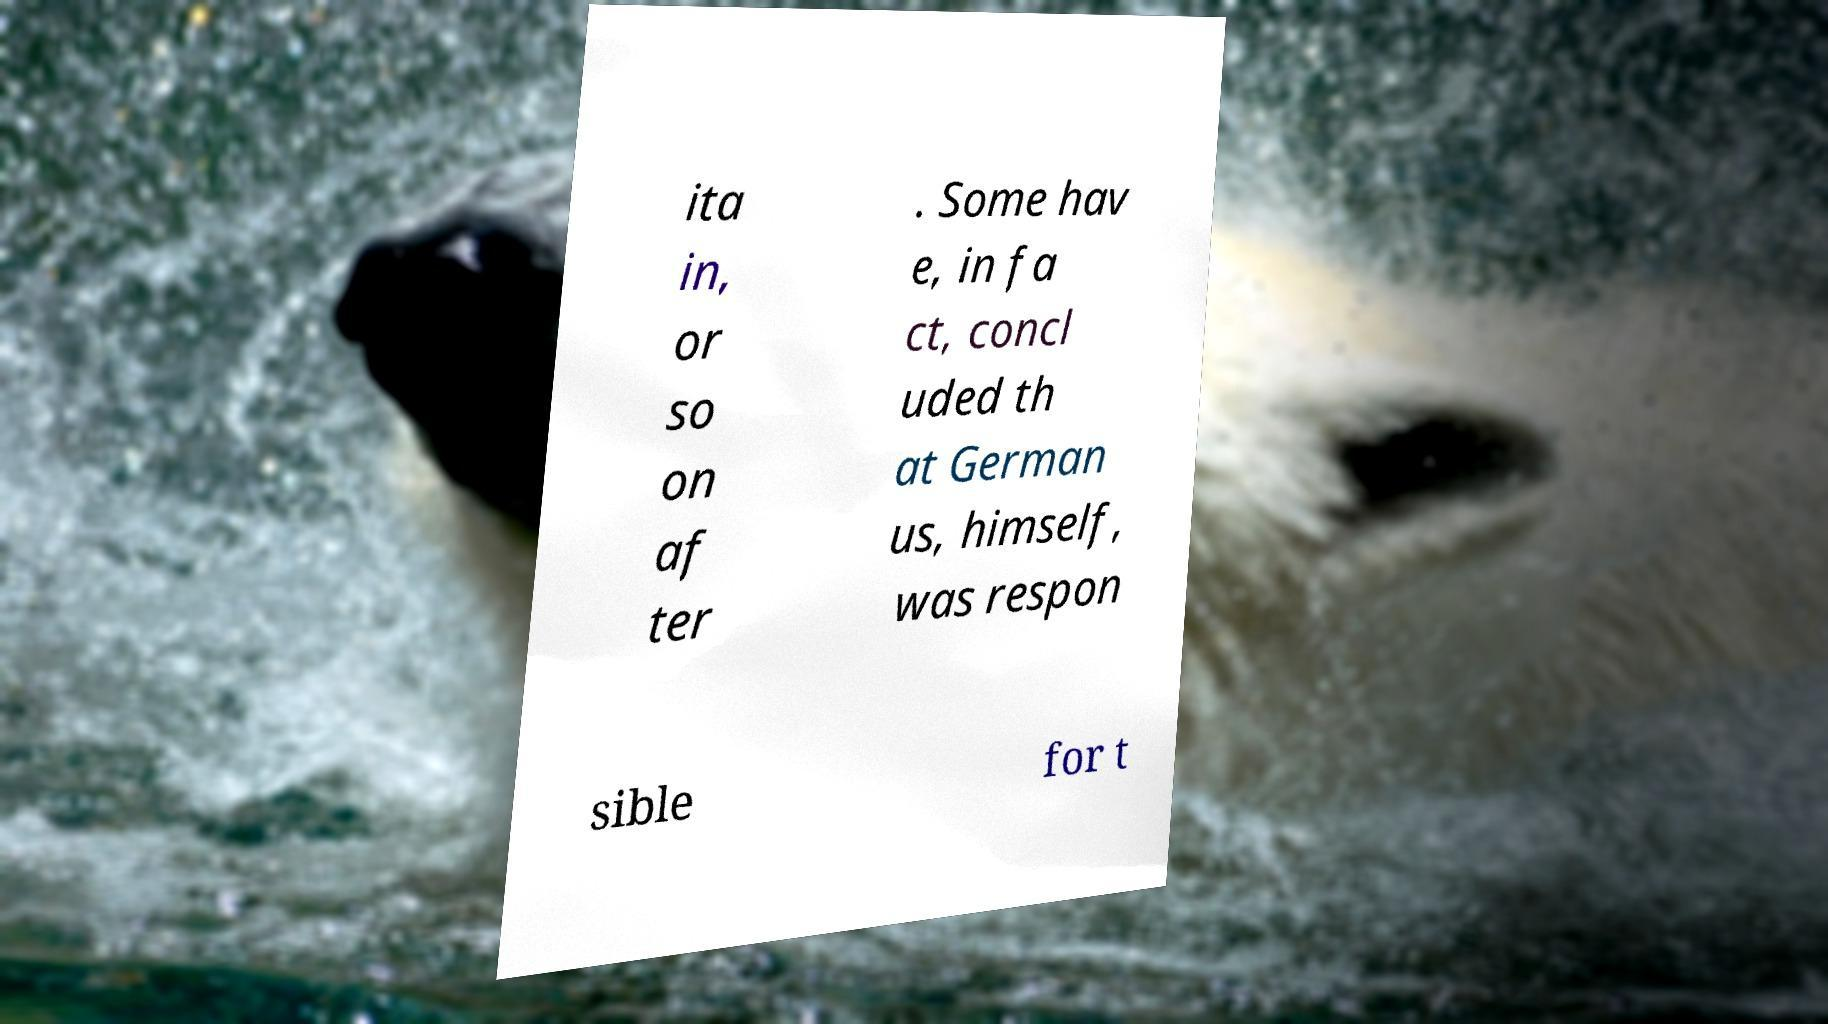Could you assist in decoding the text presented in this image and type it out clearly? ita in, or so on af ter . Some hav e, in fa ct, concl uded th at German us, himself, was respon sible for t 